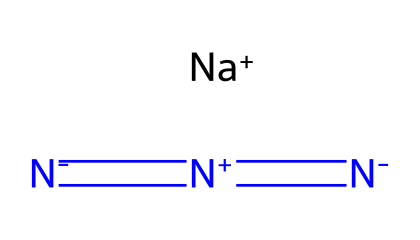How many nitrogen atoms are present in this azide compound? The SMILES representation includes three nitrogen atoms represented by the symbols "N," and they can be counted directly from the structure represented.
Answer: three What type of ion is represented by [Na+]? The [Na+] symbol in the SMILES indicates the presence of a positively charged sodium ion (cation). Sodium typically loses one electron to become positively charged, which is reflected in the notation.
Answer: cation What is the oxidation state of the nitrogen in the azide group? The nitrogen in the azide group is typically in the -1 oxidation state, as it is part of the anionic structure of azides, which contains a nitrogen-nitrogen double bond.
Answer: -1 How many total bonds are formed between the nitrogen atoms in this azide compound? There are a total of three bonds between the nitrogen atoms, with one double bond and two single bonds that connect them in the azide structure as depicted in the SMILES.
Answer: three What functional group does this compound belong to? The presence of the azide moiety, specifically indicated by the structural representation of multiple nitrogen atoms connected, classifies this compound as an azide.
Answer: azide Which property makes azide compounds useful in anti-static treatments? Azide compounds tend to be very reactive and can release nitrogen gas upon decomposition, which can help in dispersing static charges effectively.
Answer: reactivity What charge does the azide ion carry? The azide ion as represented by [N-]=[N+]=[N-] carries a net charge of -1, indicating it is an anion. This is determined from the overall structure and the charges displayed on the nitrogen atoms.
Answer: -1 